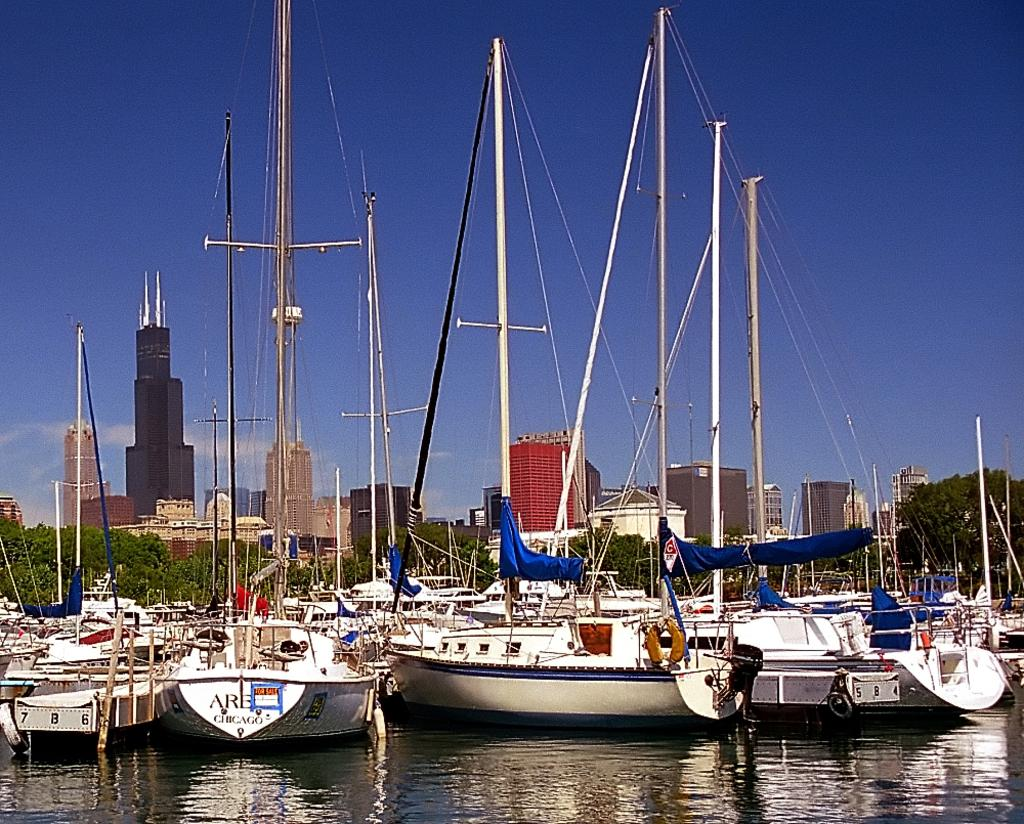<image>
Render a clear and concise summary of the photo. A for sale sign is on the back of a boat with the word Chicago on it. 